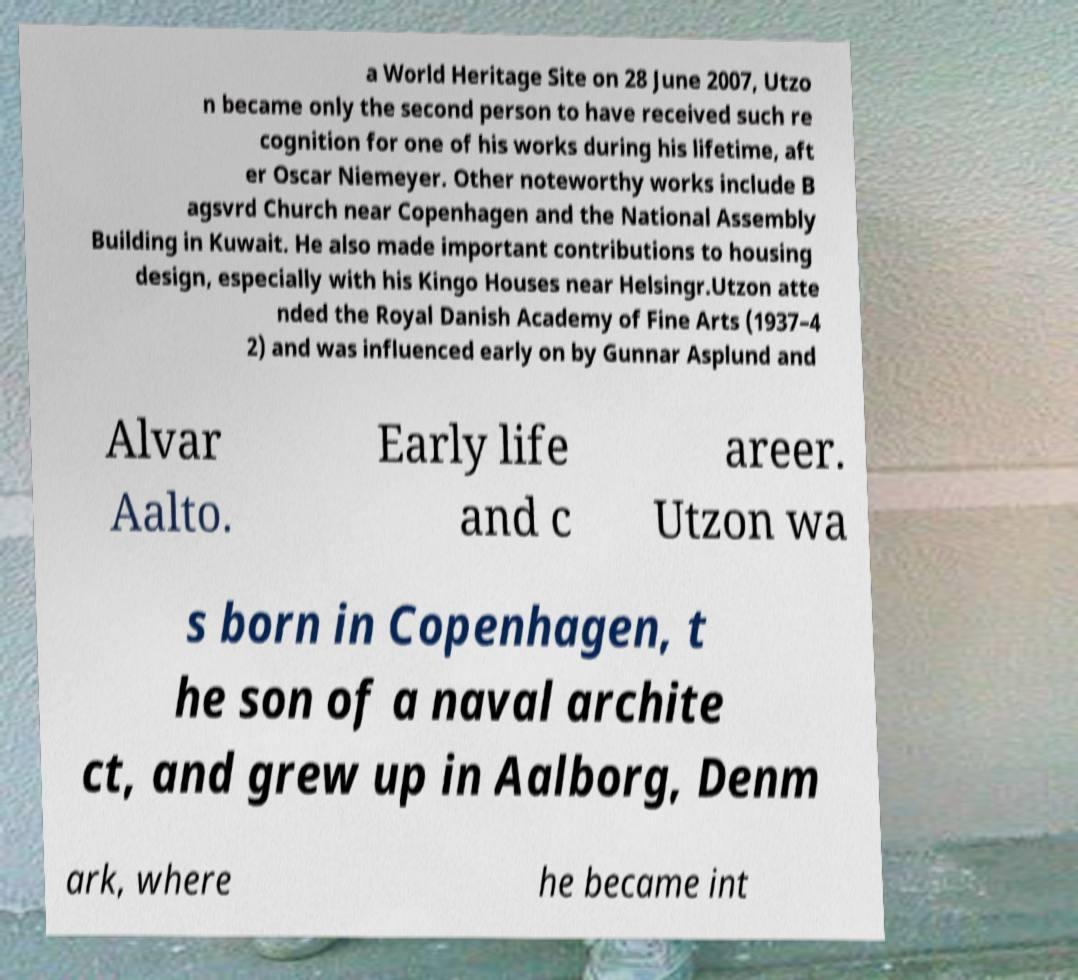Can you accurately transcribe the text from the provided image for me? a World Heritage Site on 28 June 2007, Utzo n became only the second person to have received such re cognition for one of his works during his lifetime, aft er Oscar Niemeyer. Other noteworthy works include B agsvrd Church near Copenhagen and the National Assembly Building in Kuwait. He also made important contributions to housing design, especially with his Kingo Houses near Helsingr.Utzon atte nded the Royal Danish Academy of Fine Arts (1937–4 2) and was influenced early on by Gunnar Asplund and Alvar Aalto. Early life and c areer. Utzon wa s born in Copenhagen, t he son of a naval archite ct, and grew up in Aalborg, Denm ark, where he became int 